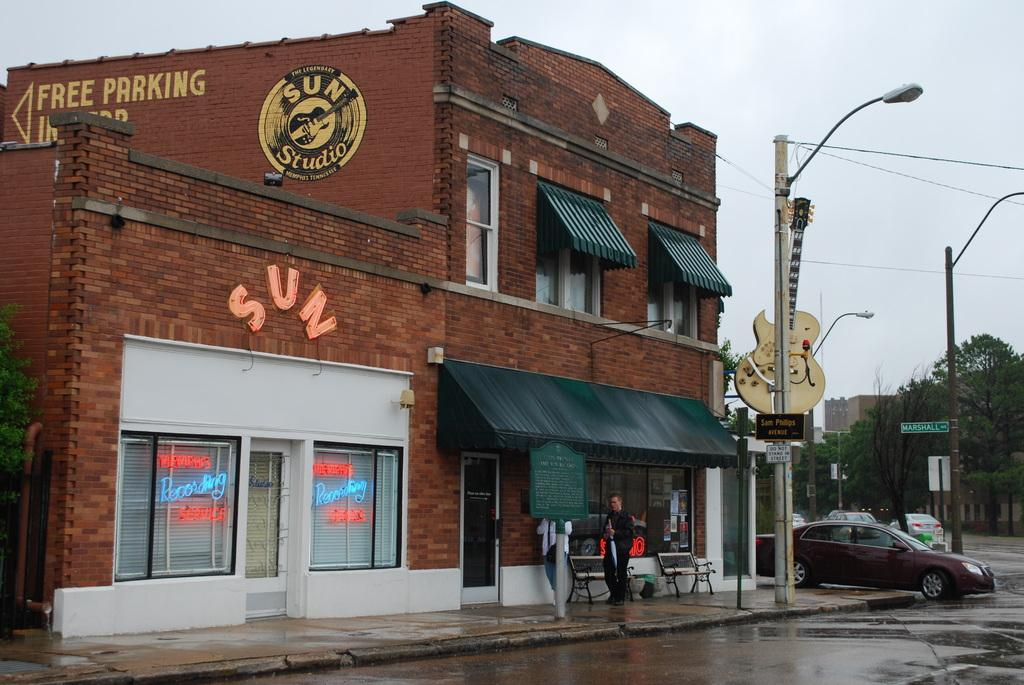<image>
Provide a brief description of the given image. A large guitar is mounted on the corner of The Legendary Sun Studio, a brick building with black awnings. 